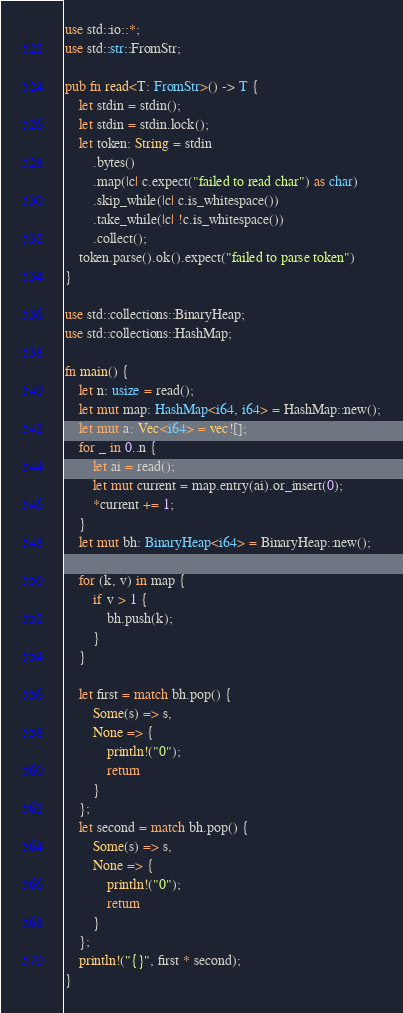<code> <loc_0><loc_0><loc_500><loc_500><_Rust_>use std::io::*;
use std::str::FromStr;

pub fn read<T: FromStr>() -> T {
    let stdin = stdin();
    let stdin = stdin.lock();
    let token: String = stdin
        .bytes()
        .map(|c| c.expect("failed to read char") as char)
        .skip_while(|c| c.is_whitespace())
        .take_while(|c| !c.is_whitespace())
        .collect();
    token.parse().ok().expect("failed to parse token")
}

use std::collections::BinaryHeap;
use std::collections::HashMap;

fn main() {
    let n: usize = read();
    let mut map: HashMap<i64, i64> = HashMap::new();
    let mut a: Vec<i64> = vec![];
    for _ in 0..n {
        let ai = read();
        let mut current = map.entry(ai).or_insert(0);
        *current += 1;
    }
    let mut bh: BinaryHeap<i64> = BinaryHeap::new();

    for (k, v) in map {
        if v > 1 {
            bh.push(k);
        }
    }

    let first = match bh.pop() {
        Some(s) => s,
        None => {
            println!("0");
            return 
        }
    };
    let second = match bh.pop() {
        Some(s) => s,
        None => {
            println!("0");
            return 
        }
    };
    println!("{}", first * second);
}
</code> 